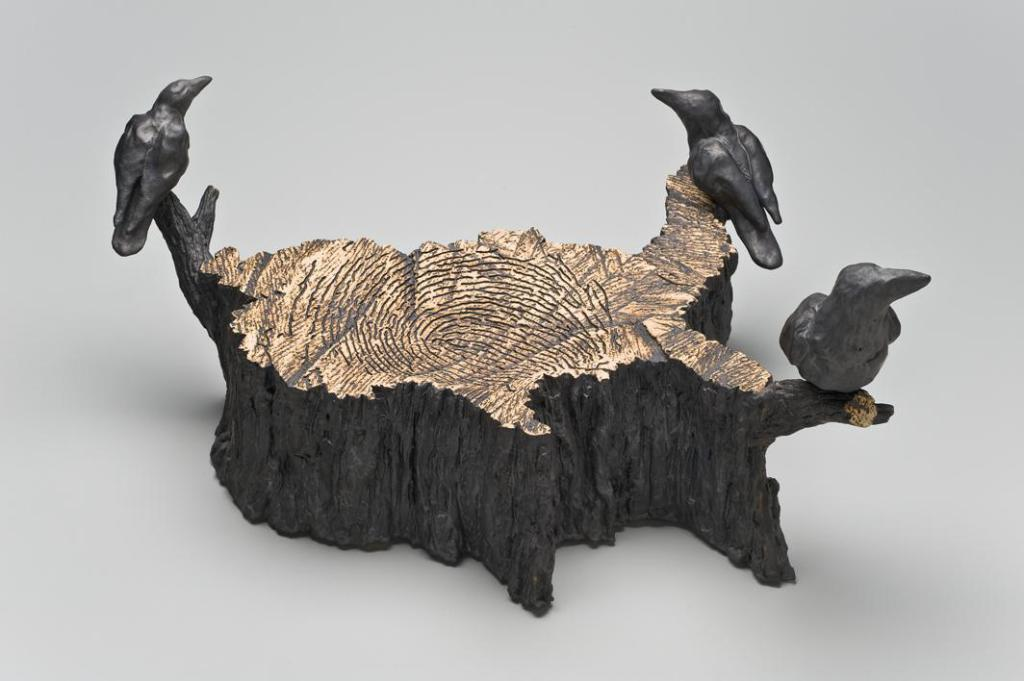What type of material is the main object in the image made of? The main object in the image is made of wood. What can be seen on the wooden object? The wooden object has depictions of birds on it. Where is the wooden object located in the image? The wooden object is located in the center of the image. What type of acoustics can be heard from the wooden object in the image? There is no indication in the image that the wooden object produces any sound, so it cannot be determined from the picture. 